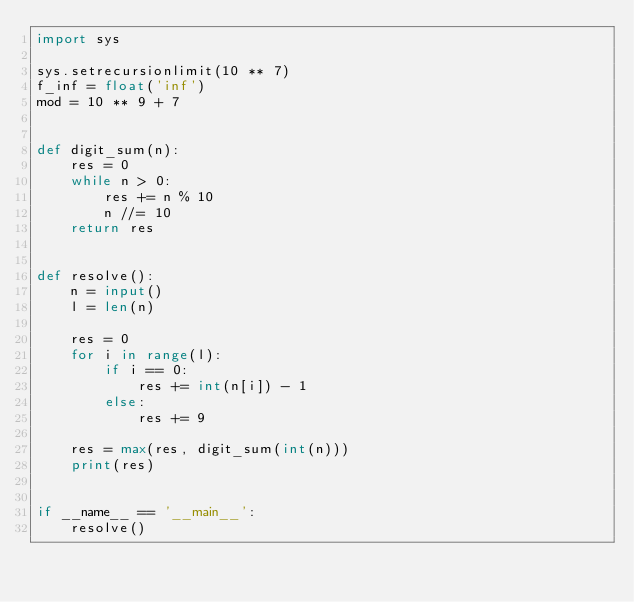Convert code to text. <code><loc_0><loc_0><loc_500><loc_500><_Python_>import sys

sys.setrecursionlimit(10 ** 7)
f_inf = float('inf')
mod = 10 ** 9 + 7


def digit_sum(n):
    res = 0
    while n > 0:
        res += n % 10
        n //= 10
    return res


def resolve():
    n = input()
    l = len(n)

    res = 0
    for i in range(l):
        if i == 0:
            res += int(n[i]) - 1
        else:
            res += 9

    res = max(res, digit_sum(int(n)))
    print(res)


if __name__ == '__main__':
    resolve()
</code> 